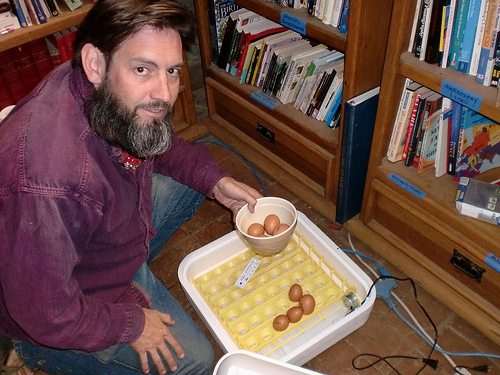<image>
Is the egg in the box? No. The egg is not contained within the box. These objects have a different spatial relationship. 